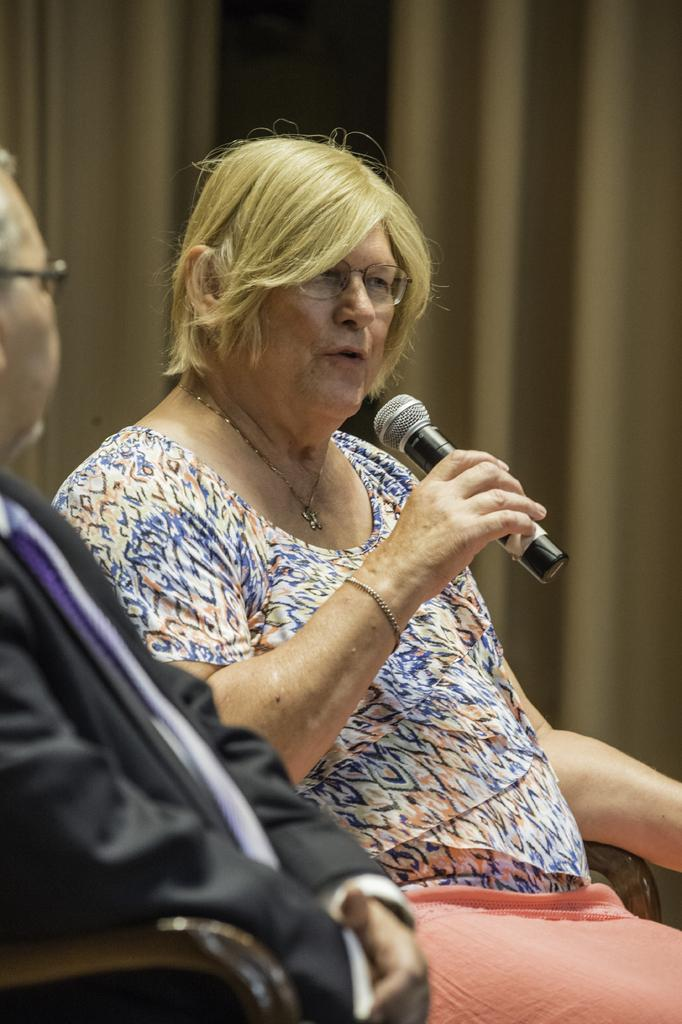What is the lady in the image wearing? The lady is wearing a t-shirt. What is the lady doing in the image? The lady is talking and holding a mic. Can you describe the man in the image? The man is sitting and wearing a suit. What can be seen in the background of the image? There is a curtain in the background of the image. What type of oatmeal is being served in the image? There is no oatmeal present in the image. How does the lady plan to increase the audience's engagement during her speech? The image does not provide information about the lady's plans to increase audience engagement. 